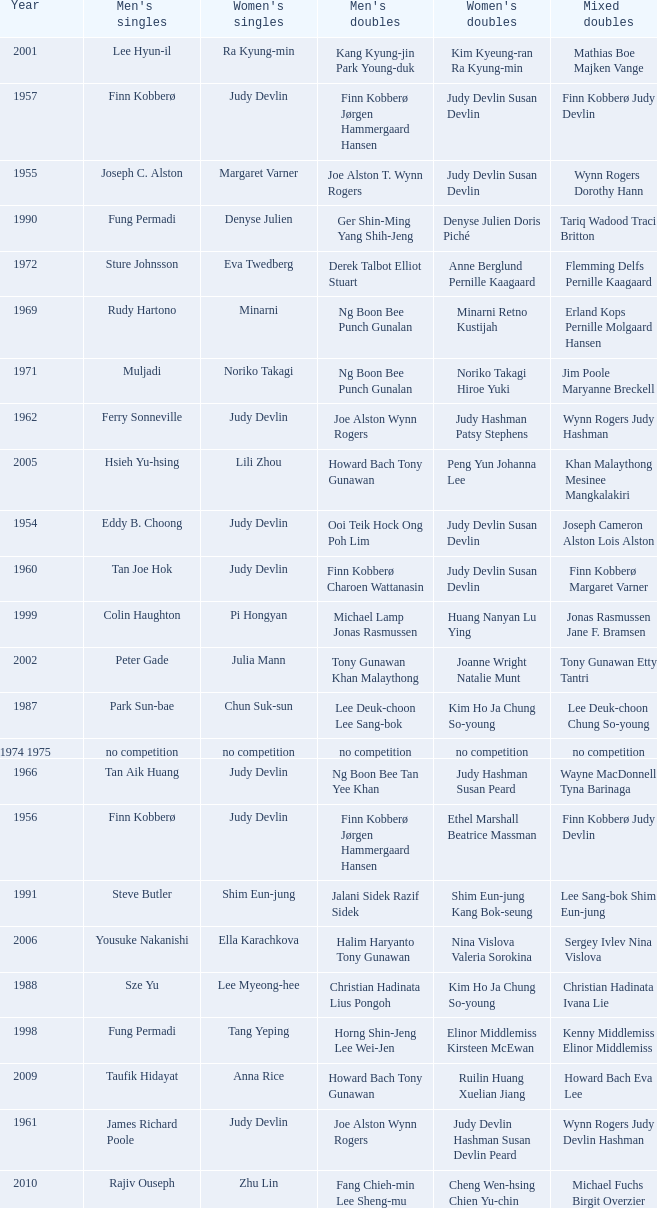Who were the men's doubles champions when the men's singles champion was muljadi? Ng Boon Bee Punch Gunalan. Parse the table in full. {'header': ['Year', "Men's singles", "Women's singles", "Men's doubles", "Women's doubles", 'Mixed doubles'], 'rows': [['2001', 'Lee Hyun-il', 'Ra Kyung-min', 'Kang Kyung-jin Park Young-duk', 'Kim Kyeung-ran Ra Kyung-min', 'Mathias Boe Majken Vange'], ['1957', 'Finn Kobberø', 'Judy Devlin', 'Finn Kobberø Jørgen Hammergaard Hansen', 'Judy Devlin Susan Devlin', 'Finn Kobberø Judy Devlin'], ['1955', 'Joseph C. Alston', 'Margaret Varner', 'Joe Alston T. Wynn Rogers', 'Judy Devlin Susan Devlin', 'Wynn Rogers Dorothy Hann'], ['1990', 'Fung Permadi', 'Denyse Julien', 'Ger Shin-Ming Yang Shih-Jeng', 'Denyse Julien Doris Piché', 'Tariq Wadood Traci Britton'], ['1972', 'Sture Johnsson', 'Eva Twedberg', 'Derek Talbot Elliot Stuart', 'Anne Berglund Pernille Kaagaard', 'Flemming Delfs Pernille Kaagaard'], ['1969', 'Rudy Hartono', 'Minarni', 'Ng Boon Bee Punch Gunalan', 'Minarni Retno Kustijah', 'Erland Kops Pernille Molgaard Hansen'], ['1971', 'Muljadi', 'Noriko Takagi', 'Ng Boon Bee Punch Gunalan', 'Noriko Takagi Hiroe Yuki', 'Jim Poole Maryanne Breckell'], ['1962', 'Ferry Sonneville', 'Judy Devlin', 'Joe Alston Wynn Rogers', 'Judy Hashman Patsy Stephens', 'Wynn Rogers Judy Hashman'], ['2005', 'Hsieh Yu-hsing', 'Lili Zhou', 'Howard Bach Tony Gunawan', 'Peng Yun Johanna Lee', 'Khan Malaythong Mesinee Mangkalakiri'], ['1954', 'Eddy B. Choong', 'Judy Devlin', 'Ooi Teik Hock Ong Poh Lim', 'Judy Devlin Susan Devlin', 'Joseph Cameron Alston Lois Alston'], ['1960', 'Tan Joe Hok', 'Judy Devlin', 'Finn Kobberø Charoen Wattanasin', 'Judy Devlin Susan Devlin', 'Finn Kobberø Margaret Varner'], ['1999', 'Colin Haughton', 'Pi Hongyan', 'Michael Lamp Jonas Rasmussen', 'Huang Nanyan Lu Ying', 'Jonas Rasmussen Jane F. Bramsen'], ['2002', 'Peter Gade', 'Julia Mann', 'Tony Gunawan Khan Malaythong', 'Joanne Wright Natalie Munt', 'Tony Gunawan Etty Tantri'], ['1987', 'Park Sun-bae', 'Chun Suk-sun', 'Lee Deuk-choon Lee Sang-bok', 'Kim Ho Ja Chung So-young', 'Lee Deuk-choon Chung So-young'], ['1974 1975', 'no competition', 'no competition', 'no competition', 'no competition', 'no competition'], ['1966', 'Tan Aik Huang', 'Judy Devlin', 'Ng Boon Bee Tan Yee Khan', 'Judy Hashman Susan Peard', 'Wayne MacDonnell Tyna Barinaga'], ['1956', 'Finn Kobberø', 'Judy Devlin', 'Finn Kobberø Jørgen Hammergaard Hansen', 'Ethel Marshall Beatrice Massman', 'Finn Kobberø Judy Devlin'], ['1991', 'Steve Butler', 'Shim Eun-jung', 'Jalani Sidek Razif Sidek', 'Shim Eun-jung Kang Bok-seung', 'Lee Sang-bok Shim Eun-jung'], ['2006', 'Yousuke Nakanishi', 'Ella Karachkova', 'Halim Haryanto Tony Gunawan', 'Nina Vislova Valeria Sorokina', 'Sergey Ivlev Nina Vislova'], ['1988', 'Sze Yu', 'Lee Myeong-hee', 'Christian Hadinata Lius Pongoh', 'Kim Ho Ja Chung So-young', 'Christian Hadinata Ivana Lie'], ['1998', 'Fung Permadi', 'Tang Yeping', 'Horng Shin-Jeng Lee Wei-Jen', 'Elinor Middlemiss Kirsteen McEwan', 'Kenny Middlemiss Elinor Middlemiss'], ['2009', 'Taufik Hidayat', 'Anna Rice', 'Howard Bach Tony Gunawan', 'Ruilin Huang Xuelian Jiang', 'Howard Bach Eva Lee'], ['1961', 'James Richard Poole', 'Judy Devlin', 'Joe Alston Wynn Rogers', 'Judy Devlin Hashman Susan Devlin Peard', 'Wynn Rogers Judy Devlin Hashman'], ['2010', 'Rajiv Ouseph', 'Zhu Lin', 'Fang Chieh-min Lee Sheng-mu', 'Cheng Wen-hsing Chien Yu-chin', 'Michael Fuchs Birgit Overzier'], ['1977 1982', 'no competition', 'no competition', 'no competition', 'no competition', 'no competition'], ['1994', 'Thomas Stuer-Lauridsen', 'Liu Guimei', 'Ade Sutrisna Candra Wijaya', 'Rikke Olsen Helene Kirkegaard', 'Jens Eriksen Rikke Olsen'], ['1967', 'Erland Kops', 'Judy Devlin', 'Erland Kops Joe Alston', 'Judy Hashman Rosine Jones Lemon', 'Jim Sydie Judy Hashman'], ['1968', 'Channarong Ratanaseangsuang', 'Tyna Barinaga', 'Jim Poole Don Paup', 'Tyna Barinaga Helen Tibbetts', 'Larry Saben Carlene Starkey'], ['2007', 'Lee Tsuen Seng', 'Jun Jae-youn', 'Tadashi Ohtsuka Keita Masuda', 'Miyuki Maeda Satoko Suetsuna', 'Keita Masuda Miyuki Maeda'], ['1973', 'Sture Johnsson', 'Eva Twedberg', 'Jim Poole Don Paup', 'Pam Brady Diane Hales', 'Sture Johnsson Eva Twedberg'], ['1992', 'Poul-Erik Hoyer-Larsen', 'Lim Xiaoqing', 'Cheah Soon Kit Soo Beng Kiang', 'Lim Xiaoqing Christine Magnusson', 'Thomas Lund Pernille Dupont'], ['1964', 'Channarong Ratanaseangsuang', "Dorothy O'Neil", 'Joe Alston Wynn Rogers', 'Tyna Barinaga Caroline Jensen', 'Channarong Ratanaseangsuang Margaret Barrand'], ['2003', 'Chien Yu-hsiu', 'Kelly Morgan', 'Tony Gunawan Khan Malaythong', 'Yoshiko Iwata Miyuki Tai', 'Tony Gunawan Eti Gunawan'], ['1989', 'no competition', 'no competition', 'no competition', 'no competition', 'no competition'], ['1976', 'Paul Whetnall', 'Gillian Gilks', 'Willi Braun Roland Maywald', 'Gillian Gilks Susan Whetnall', 'David Eddy Susan Whetnall'], ['2013', 'Nguyen Tien Minh', 'Sapsiree Taerattanachai', 'Takeshi Kamura Keigo Sonoda', 'Bao Yixin Zhong Qianxin', 'Lee Chun Hei Chau Hoi Wah'], ['1970', 'Junji Honma', 'Etsuko Takenaka', 'Junji Honma Ippei Kojima', 'Etsuko Takenaka Machiko Aizawa', 'Paul Whetnall Margaret Boxall'], ['1985', 'Mike Butler', 'Claire Backhouse Sharpe', 'John Britton Gary Higgins', 'Claire Sharpe Sandra Skillings', 'Mike Butler Claire Sharpe'], ['1997', 'Poul-Erik Hoyer-Larsen', 'Camilla Martin', 'Ha Tae-kwon Kim Dong-moon', 'Qin Yiyuan Tang Yongshu', 'Kim Dong Moon Ra Kyung-min'], ['2004', 'Kendrick Lee Yen Hui', 'Xing Aiying', 'Howard Bach Tony Gunawan', 'Cheng Wen-hsing Chien Yu-chin', 'Lin Wei-hsiang Cheng Wen-hsing'], ['2012', 'Vladimir Ivanov', 'Pai Hsiao-ma', 'Hiroyuki Endo Kenichi Hayakawa', 'Misaki Matsutomo Ayaka Takahashi', 'Tony Gunawan Vita Marissa'], ['1996', 'Joko Suprianto', 'Mia Audina', 'Candra Wijaya Sigit Budiarto', 'Zelin Resiana Eliza Nathanael', 'Kim Dong-moon Chung So-young'], ['1993', 'Marleve Mainaky', 'Lim Xiaoqing', 'Thomas Lund Jon Holst-Christensen', 'Gil Young-ah Chung So-young', 'Thomas Lund Catrine Bengtsson'], ['1983', 'Mike Butler', 'Sherrie Liu', 'John Britton Gary Higgins', 'Claire Backhouse Johanne Falardeau', 'Mike Butler Claire Backhouse'], ['2000', 'Ardy Wiranata', 'Choi Ma-re', 'Graham Hurrell James Anderson', 'Gail Emms Joanne Wright', 'Jonas Rasmussen Jane F. Bramsen'], ['1958', 'James Richard Poole', 'Judy Devlin', 'Finn Kobberø Jørgen Hammergaard Hansen', 'Judy Devlin Susan Devlin', 'Finn Kobberø Jørgen Hammergaard Hansen'], ['1963', 'Erland Kops', 'Judy Devlin', 'Erland Kops Bob McCoig', 'Judy Hashman Susan Peard', 'Sangob Rattanusorn Margaret Barrand'], ['1965', 'Erland Kops', 'Judy Devlin', 'Bob McCoig Tony Jordan', 'Margaret Barrand Jennifer Pritchard', 'Bob McCoig Margaret Barrand'], ['2008', 'Andrew Dabeka', 'Lili Zhou', 'Howard Bach Khan Malaythong', 'Chang Li-Ying Hung Shih-Chieh', 'Halim Haryanto Peng Yun'], ['1984', 'Xiong Guobao', 'Luo Yun', 'Chen Hongyong Zhang Qingwu', 'Yin Haichen Lu Yanahua', 'Wang Pengren Luo Yun'], ['1959', 'Tan Joe Hok', 'Judy Devlin', 'Teh Kew San Lim Say Hup', 'Judy Devlin Susan Devlin', 'Michael Roche Judy Devlin'], ['2011', 'Sho Sasaki', 'Tai Tzu-ying', 'Ko Sung-hyun Lee Yong-dae', 'Ha Jung-eun Kim Min-jung', 'Lee Yong-dae Ha Jung-eun'], ['1995', 'Hermawan Susanto', 'Ye Zhaoying', 'Rudy Gunawan Joko Suprianto', 'Gil Young-ah Jang Hye-ock', 'Kim Dong-moon Gil Young-ah'], ['1986', 'Sung Han-kuk', 'Denyse Julien', 'Yao Ximing Tariq Wadood', 'Denyse Julien Johanne Falardeau', 'Mike Butler Johanne Falardeau']]} 